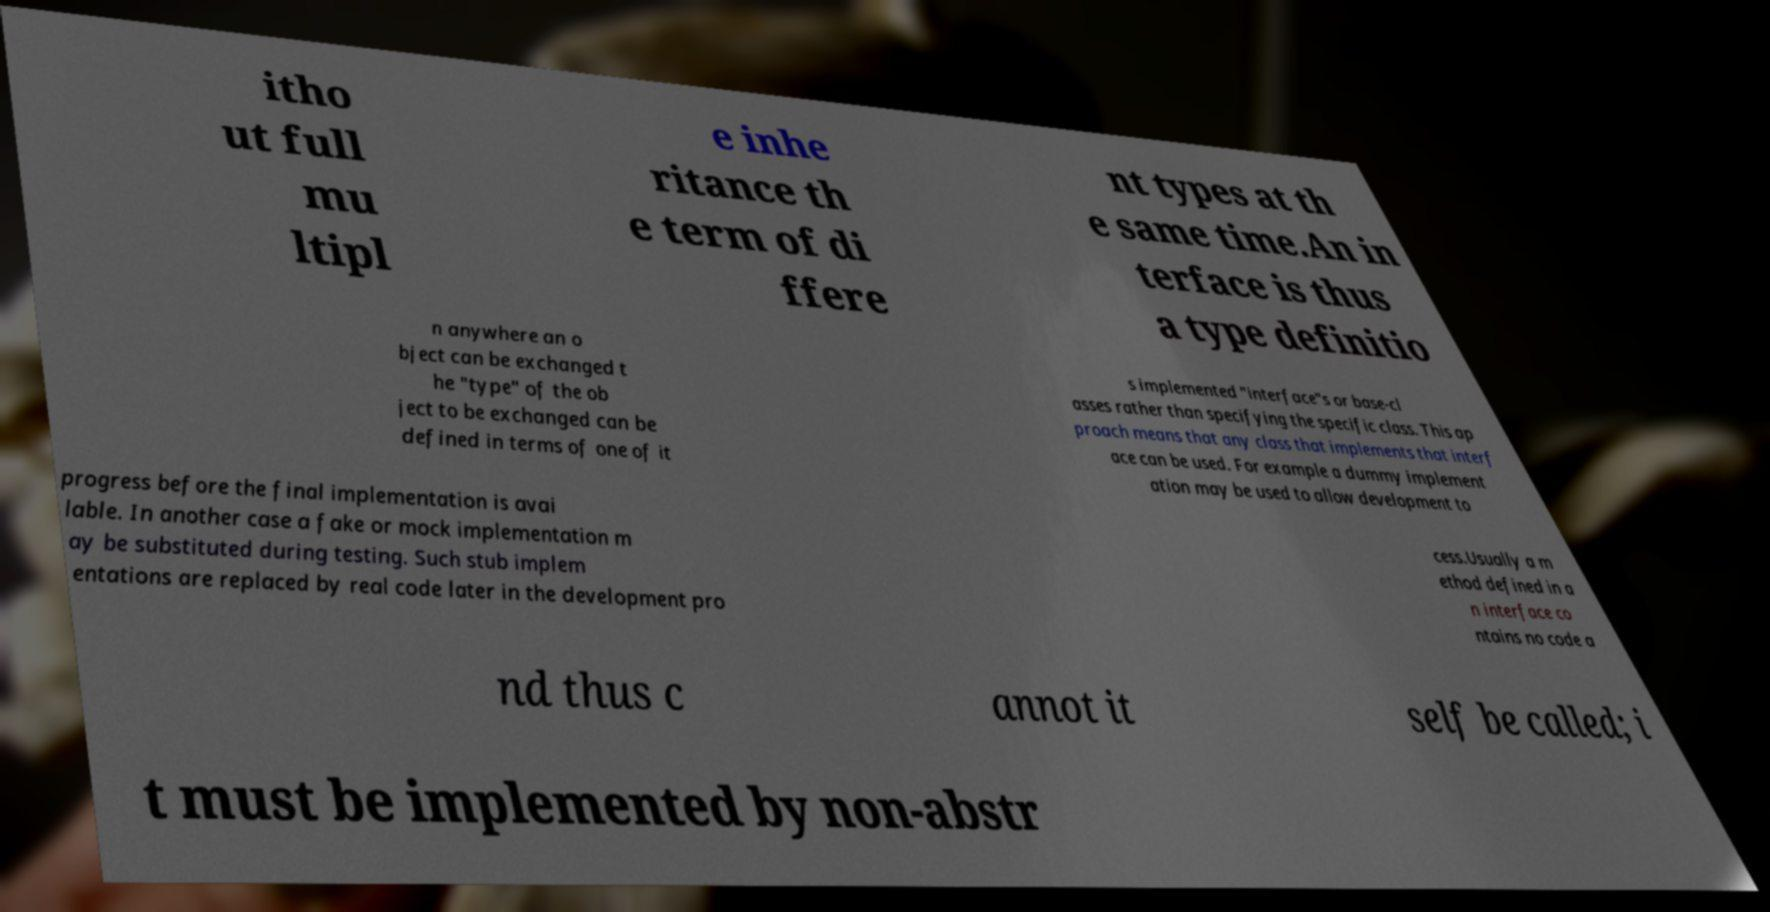Can you read and provide the text displayed in the image?This photo seems to have some interesting text. Can you extract and type it out for me? itho ut full mu ltipl e inhe ritance th e term of di ffere nt types at th e same time.An in terface is thus a type definitio n anywhere an o bject can be exchanged t he "type" of the ob ject to be exchanged can be defined in terms of one of it s implemented "interface"s or base-cl asses rather than specifying the specific class. This ap proach means that any class that implements that interf ace can be used. For example a dummy implement ation may be used to allow development to progress before the final implementation is avai lable. In another case a fake or mock implementation m ay be substituted during testing. Such stub implem entations are replaced by real code later in the development pro cess.Usually a m ethod defined in a n interface co ntains no code a nd thus c annot it self be called; i t must be implemented by non-abstr 